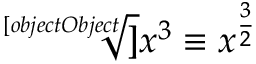<formula> <loc_0><loc_0><loc_500><loc_500>{ { { \sqrt { [ } [ o b j e c t O b j e c t ] ] { x ^ { 3 } } } \equiv x ^ { \frac { 3 } { 2 } } } }</formula> 